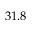<formula> <loc_0><loc_0><loc_500><loc_500>3 1 . 8</formula> 